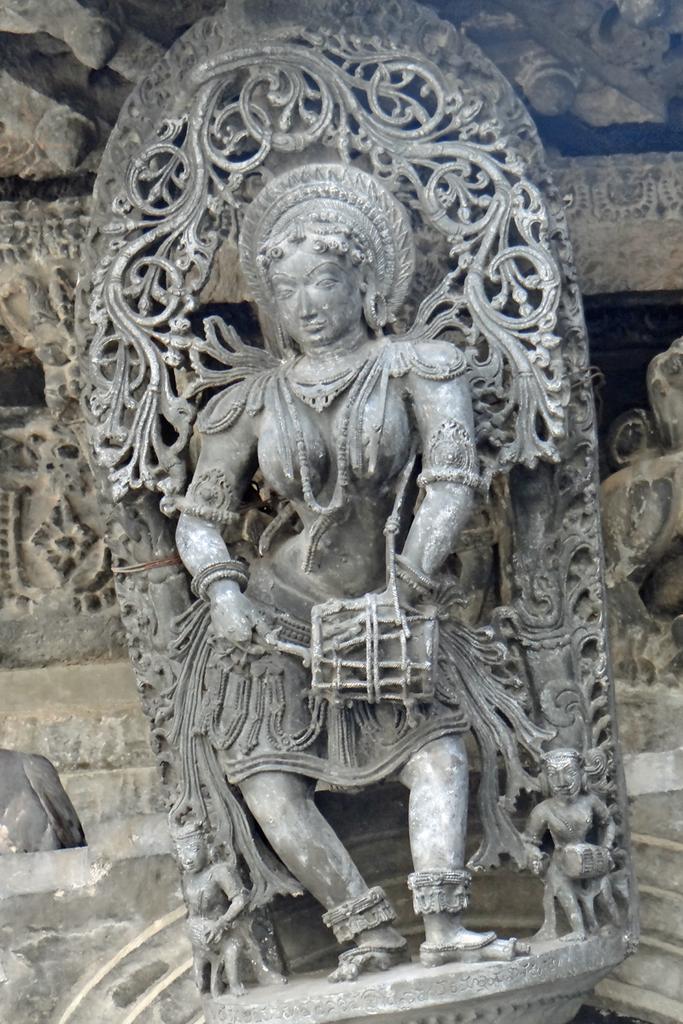Describe this image in one or two sentences. In this picture I can observe sculpture of a woman. In the background I can observe some carvings on the stones. 